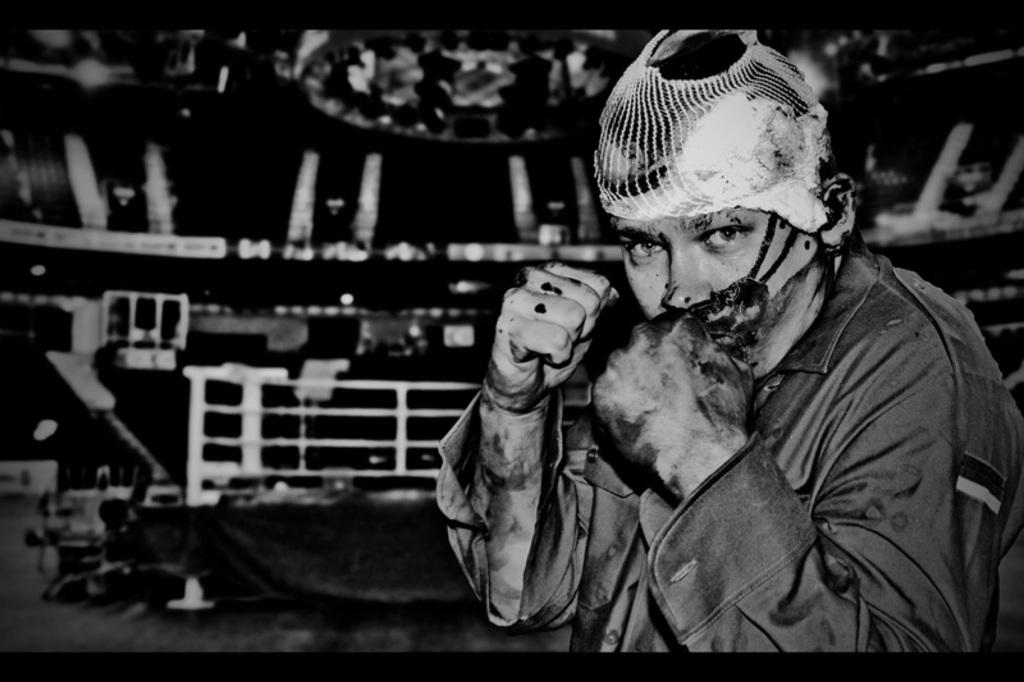What is the main subject of the image? The main subject of the image is a man. What can be said about the color scheme of the image? The image is a black and white photography. What type of guide is the man holding in the image? There is no guide visible in the image; it only features a man. What hobbies can be seen the man engaging in the image? There is no indication of any hobbies in the image, as it only shows a man. What type of reading material is the man holding in the image? There is no reading material visible in the image, as it only features a man. 